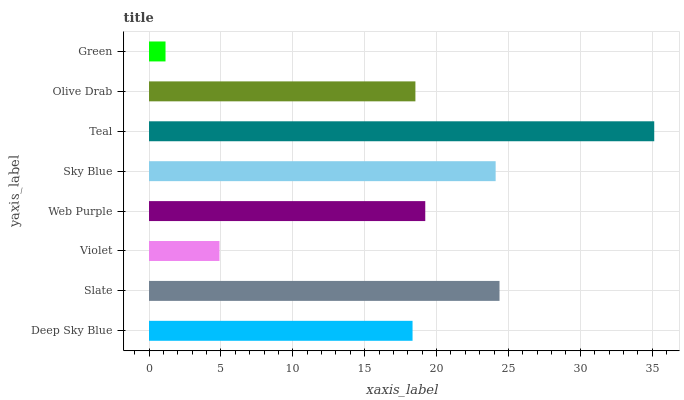Is Green the minimum?
Answer yes or no. Yes. Is Teal the maximum?
Answer yes or no. Yes. Is Slate the minimum?
Answer yes or no. No. Is Slate the maximum?
Answer yes or no. No. Is Slate greater than Deep Sky Blue?
Answer yes or no. Yes. Is Deep Sky Blue less than Slate?
Answer yes or no. Yes. Is Deep Sky Blue greater than Slate?
Answer yes or no. No. Is Slate less than Deep Sky Blue?
Answer yes or no. No. Is Web Purple the high median?
Answer yes or no. Yes. Is Olive Drab the low median?
Answer yes or no. Yes. Is Violet the high median?
Answer yes or no. No. Is Violet the low median?
Answer yes or no. No. 